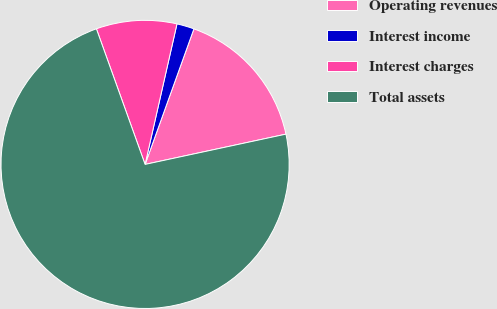Convert chart to OTSL. <chart><loc_0><loc_0><loc_500><loc_500><pie_chart><fcel>Operating revenues<fcel>Interest income<fcel>Interest charges<fcel>Total assets<nl><fcel>16.13%<fcel>1.95%<fcel>9.04%<fcel>72.88%<nl></chart> 